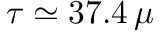Convert formula to latex. <formula><loc_0><loc_0><loc_500><loc_500>\tau \simeq 3 7 . 4 \, \mu</formula> 